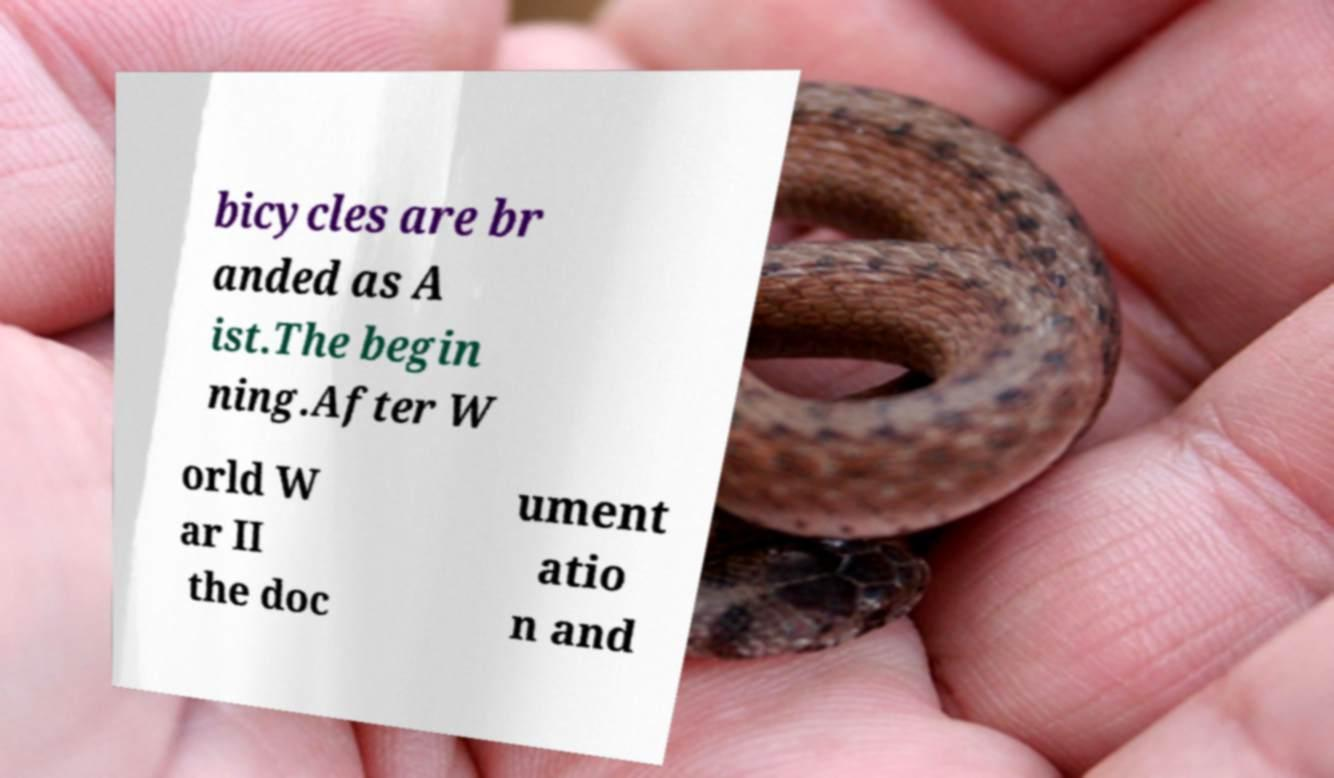There's text embedded in this image that I need extracted. Can you transcribe it verbatim? bicycles are br anded as A ist.The begin ning.After W orld W ar II the doc ument atio n and 